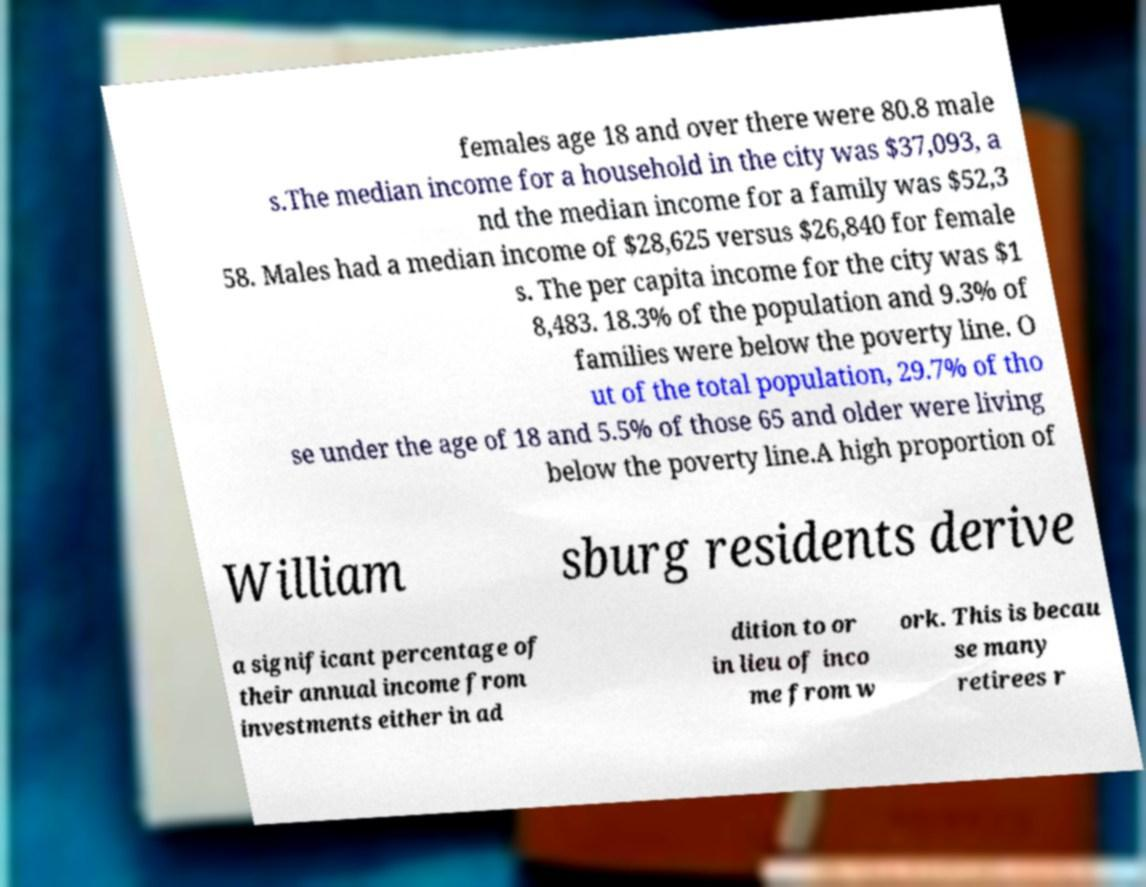Can you read and provide the text displayed in the image?This photo seems to have some interesting text. Can you extract and type it out for me? females age 18 and over there were 80.8 male s.The median income for a household in the city was $37,093, a nd the median income for a family was $52,3 58. Males had a median income of $28,625 versus $26,840 for female s. The per capita income for the city was $1 8,483. 18.3% of the population and 9.3% of families were below the poverty line. O ut of the total population, 29.7% of tho se under the age of 18 and 5.5% of those 65 and older were living below the poverty line.A high proportion of William sburg residents derive a significant percentage of their annual income from investments either in ad dition to or in lieu of inco me from w ork. This is becau se many retirees r 